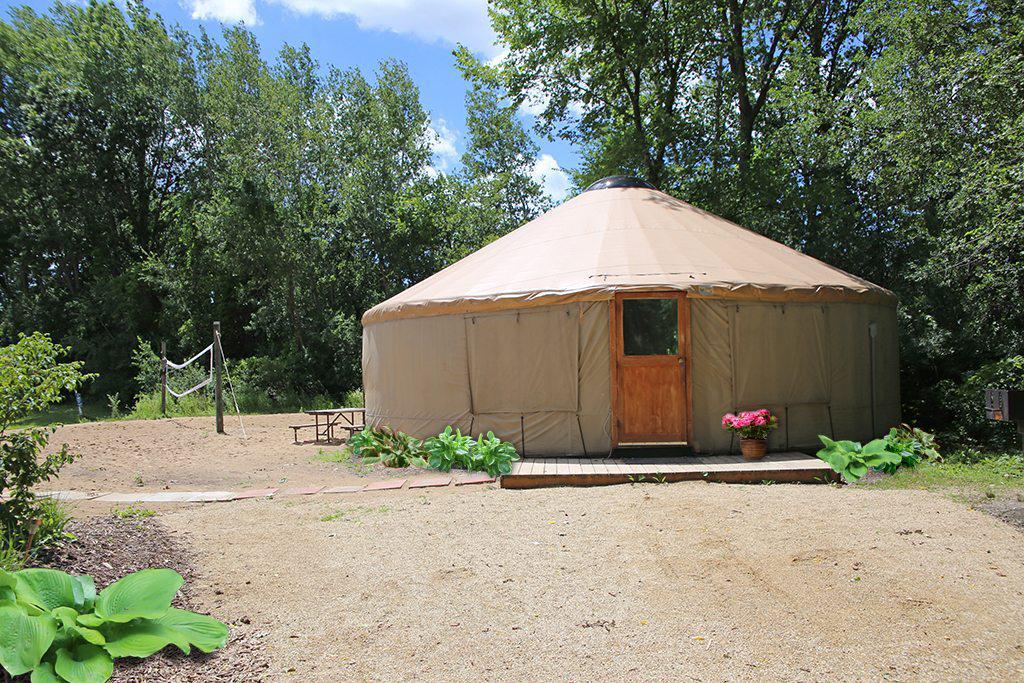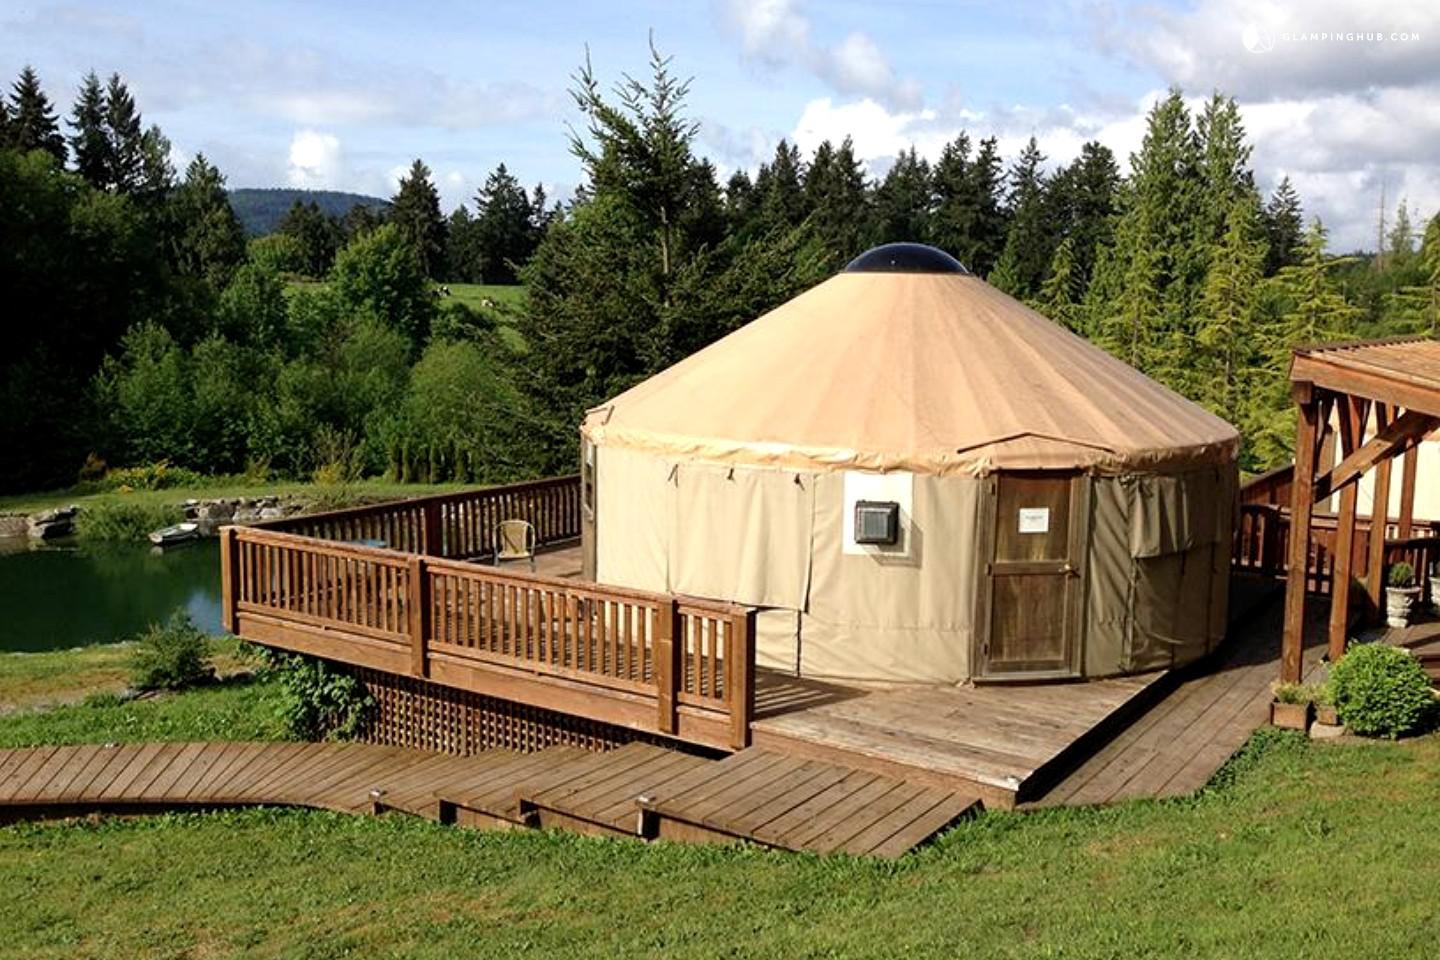The first image is the image on the left, the second image is the image on the right. Examine the images to the left and right. Is the description "There is a structure with a wooden roof to the right of the yurt in the image on the right." accurate? Answer yes or no. Yes. 